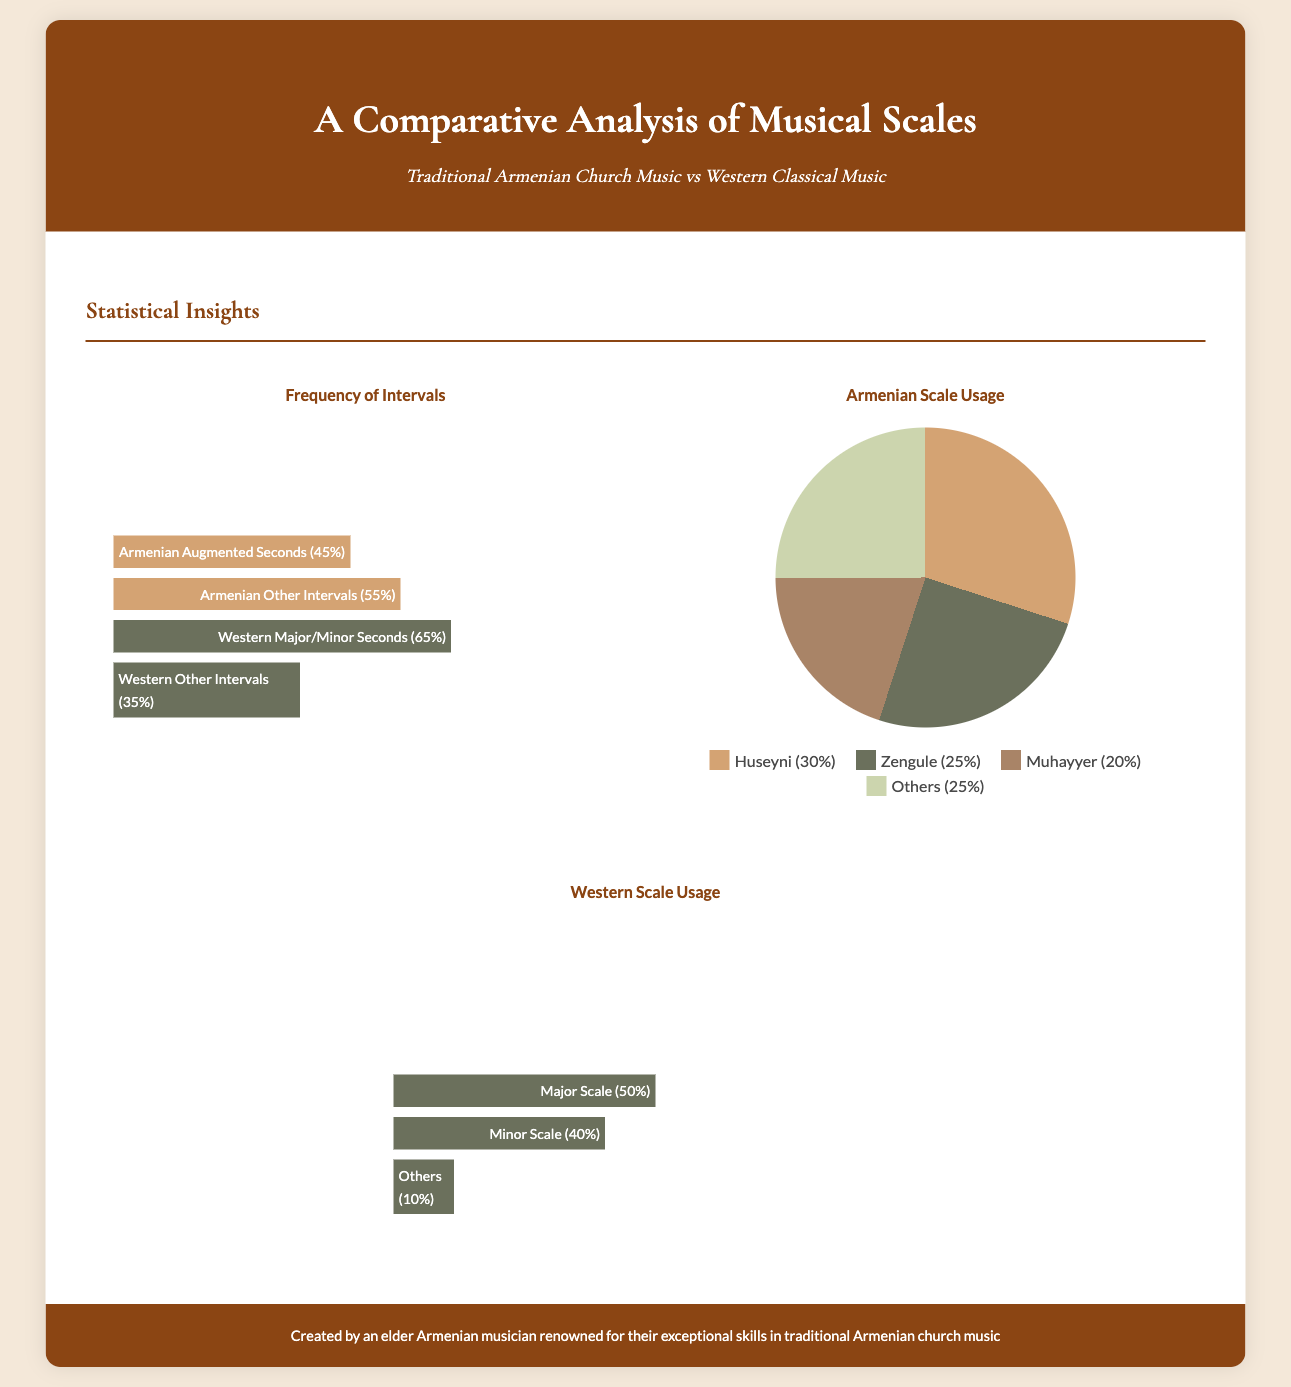What is the percentage of Armenian Augmented Seconds? The document states that Armenian Augmented Seconds make up 45% of the intervals.
Answer: 45% What is the highest percentage of intervals for Western music? According to the infographic, Western Major/Minor Seconds are at 65%, which is the highest percentage.
Answer: 65% Which Armenian scale has the lowest percentage? The lowest percentage among the Armenian scales is for Muhayyer, at 20%.
Answer: Muhayyer What section discusses the usage of Armenian scales? The section titled "Armenian Scale Usage" provides insights into the different Armenian scales used.
Answer: Armenian Scale Usage How much of the Western music scales is classified as 'Others'? The 'Others' category for Western music scales accounts for 10%.
Answer: 10% Which scale accounts for the largest share in Armenian music? The Huseyni scale accounts for the largest share at 30%.
Answer: Huseyni What is the total percentage of Armenian Other Intervals? The total percentage of Armenian Other Intervals is 55%.
Answer: 55% What color represents the Zengule scale in the pie chart? The Zengule scale is represented by a dark green color in the pie chart.
Answer: Dark Green What is the total percentage of the Major and Minor scales together in Western music? The total is 50% for Major and 40% for Minor, which sums up to 90%.
Answer: 90% 